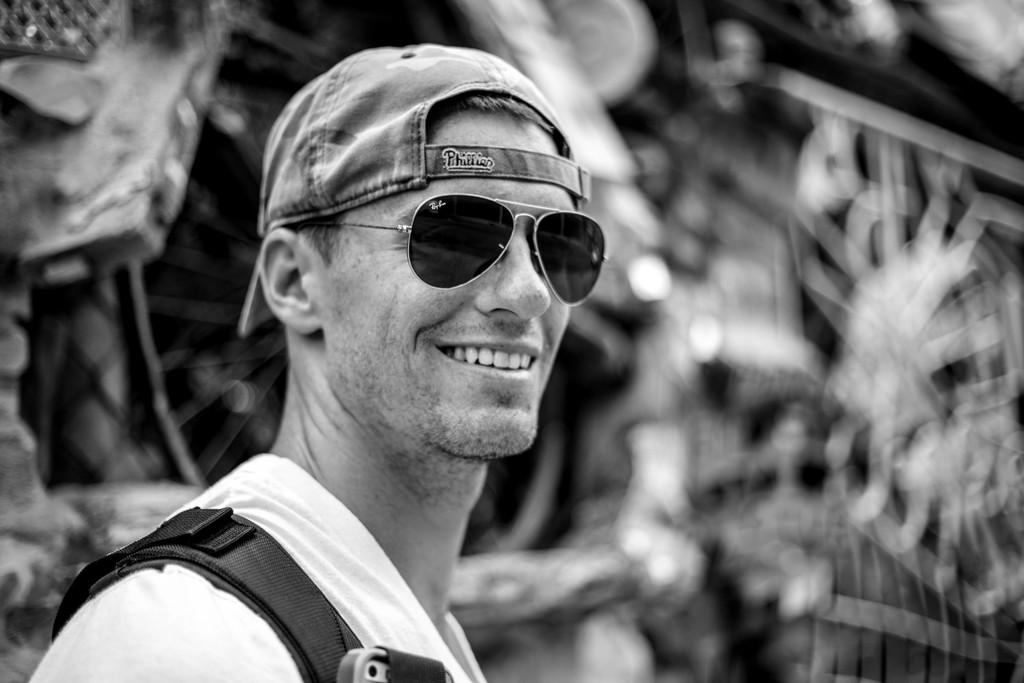What can be seen in the image? There is a person in the image. Can you describe the person's appearance? The person is wearing a cap and glasses. What is the color scheme of the image? The image is in black and white. How would you describe the background of the image? The background of the image is blurred. What type of reward can be seen hanging from the bushes in the image? There are no bushes or rewards present in the image; it features a person wearing a cap and glasses in a black and white, blurred background. 